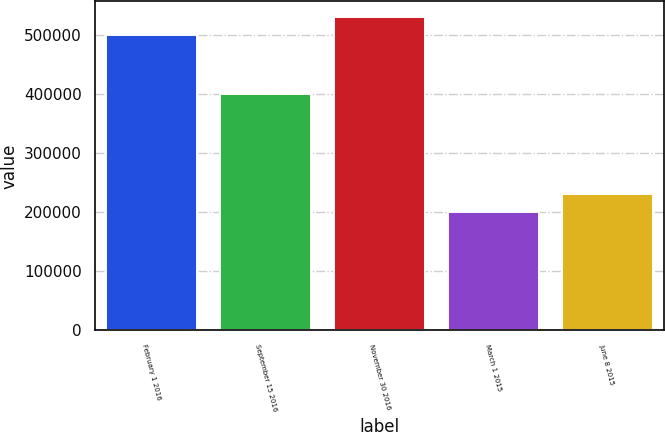Convert chart. <chart><loc_0><loc_0><loc_500><loc_500><bar_chart><fcel>February 1 2016<fcel>September 15 2016<fcel>November 30 2016<fcel>March 1 2015<fcel>June 8 2015<nl><fcel>500000<fcel>400000<fcel>530000<fcel>200000<fcel>230000<nl></chart> 